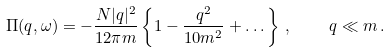Convert formula to latex. <formula><loc_0><loc_0><loc_500><loc_500>\Pi ( { q } , \omega ) = - \frac { N | { q } | ^ { 2 } } { 1 2 \pi m } \left \{ 1 - \frac { q ^ { 2 } } { 1 0 m ^ { 2 } } + \dots \right \} \, , \quad q \ll m \, .</formula> 